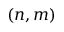Convert formula to latex. <formula><loc_0><loc_0><loc_500><loc_500>( n , m )</formula> 